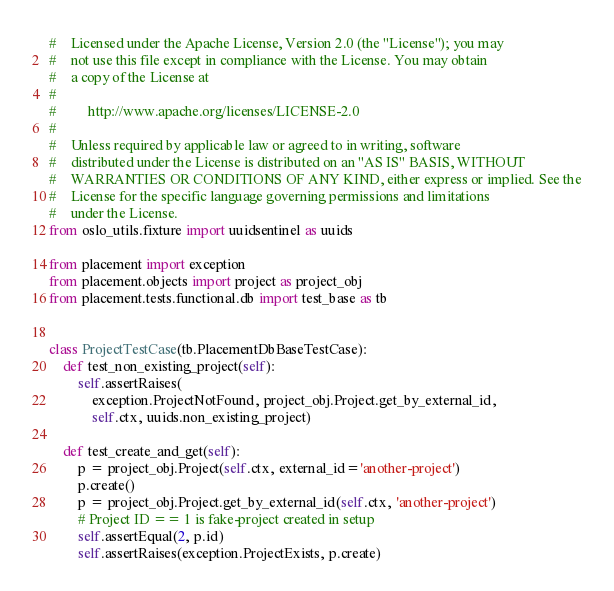Convert code to text. <code><loc_0><loc_0><loc_500><loc_500><_Python_>#    Licensed under the Apache License, Version 2.0 (the "License"); you may
#    not use this file except in compliance with the License. You may obtain
#    a copy of the License at
#
#         http://www.apache.org/licenses/LICENSE-2.0
#
#    Unless required by applicable law or agreed to in writing, software
#    distributed under the License is distributed on an "AS IS" BASIS, WITHOUT
#    WARRANTIES OR CONDITIONS OF ANY KIND, either express or implied. See the
#    License for the specific language governing permissions and limitations
#    under the License.
from oslo_utils.fixture import uuidsentinel as uuids

from placement import exception
from placement.objects import project as project_obj
from placement.tests.functional.db import test_base as tb


class ProjectTestCase(tb.PlacementDbBaseTestCase):
    def test_non_existing_project(self):
        self.assertRaises(
            exception.ProjectNotFound, project_obj.Project.get_by_external_id,
            self.ctx, uuids.non_existing_project)

    def test_create_and_get(self):
        p = project_obj.Project(self.ctx, external_id='another-project')
        p.create()
        p = project_obj.Project.get_by_external_id(self.ctx, 'another-project')
        # Project ID == 1 is fake-project created in setup
        self.assertEqual(2, p.id)
        self.assertRaises(exception.ProjectExists, p.create)
</code> 